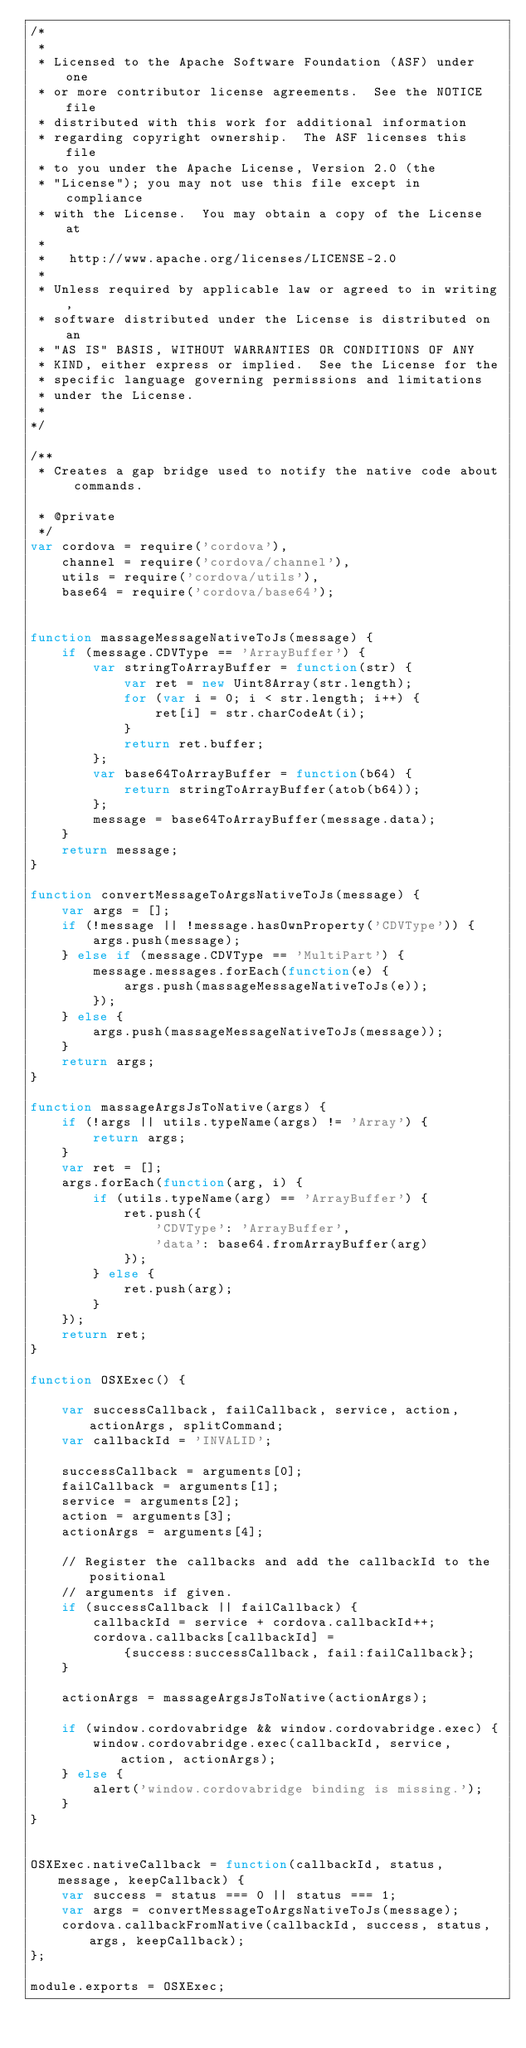Convert code to text. <code><loc_0><loc_0><loc_500><loc_500><_JavaScript_>/*
 *
 * Licensed to the Apache Software Foundation (ASF) under one
 * or more contributor license agreements.  See the NOTICE file
 * distributed with this work for additional information
 * regarding copyright ownership.  The ASF licenses this file
 * to you under the Apache License, Version 2.0 (the
 * "License"); you may not use this file except in compliance
 * with the License.  You may obtain a copy of the License at
 *
 *   http://www.apache.org/licenses/LICENSE-2.0
 *
 * Unless required by applicable law or agreed to in writing,
 * software distributed under the License is distributed on an
 * "AS IS" BASIS, WITHOUT WARRANTIES OR CONDITIONS OF ANY
 * KIND, either express or implied.  See the License for the
 * specific language governing permissions and limitations
 * under the License.
 *
*/

/**
 * Creates a gap bridge used to notify the native code about commands.

 * @private
 */
var cordova = require('cordova'),
    channel = require('cordova/channel'),
    utils = require('cordova/utils'),
    base64 = require('cordova/base64');


function massageMessageNativeToJs(message) {
    if (message.CDVType == 'ArrayBuffer') {
        var stringToArrayBuffer = function(str) {
            var ret = new Uint8Array(str.length);
            for (var i = 0; i < str.length; i++) {
                ret[i] = str.charCodeAt(i);
            }
            return ret.buffer;
        };
        var base64ToArrayBuffer = function(b64) {
            return stringToArrayBuffer(atob(b64));
        };
        message = base64ToArrayBuffer(message.data);
    }
    return message;
}

function convertMessageToArgsNativeToJs(message) {
    var args = [];
    if (!message || !message.hasOwnProperty('CDVType')) {
        args.push(message);
    } else if (message.CDVType == 'MultiPart') {
        message.messages.forEach(function(e) {
            args.push(massageMessageNativeToJs(e));
        });
    } else {
        args.push(massageMessageNativeToJs(message));
    }
    return args;
}

function massageArgsJsToNative(args) {
    if (!args || utils.typeName(args) != 'Array') {
        return args;
    }
    var ret = [];
    args.forEach(function(arg, i) {
        if (utils.typeName(arg) == 'ArrayBuffer') {
            ret.push({
                'CDVType': 'ArrayBuffer',
                'data': base64.fromArrayBuffer(arg)
            });
        } else {
            ret.push(arg);
        }
    });
    return ret;
}

function OSXExec() {

    var successCallback, failCallback, service, action, actionArgs, splitCommand;
    var callbackId = 'INVALID';

    successCallback = arguments[0];
    failCallback = arguments[1];
    service = arguments[2];
    action = arguments[3];
    actionArgs = arguments[4];

    // Register the callbacks and add the callbackId to the positional
    // arguments if given.
    if (successCallback || failCallback) {
        callbackId = service + cordova.callbackId++;
        cordova.callbacks[callbackId] =
            {success:successCallback, fail:failCallback};
    }

    actionArgs = massageArgsJsToNative(actionArgs);

    if (window.cordovabridge && window.cordovabridge.exec) {
        window.cordovabridge.exec(callbackId, service, action, actionArgs);
    } else {
        alert('window.cordovabridge binding is missing.');
    }
}


OSXExec.nativeCallback = function(callbackId, status, message, keepCallback) {
    var success = status === 0 || status === 1;
    var args = convertMessageToArgsNativeToJs(message);
    cordova.callbackFromNative(callbackId, success, status, args, keepCallback);
};

module.exports = OSXExec;
</code> 